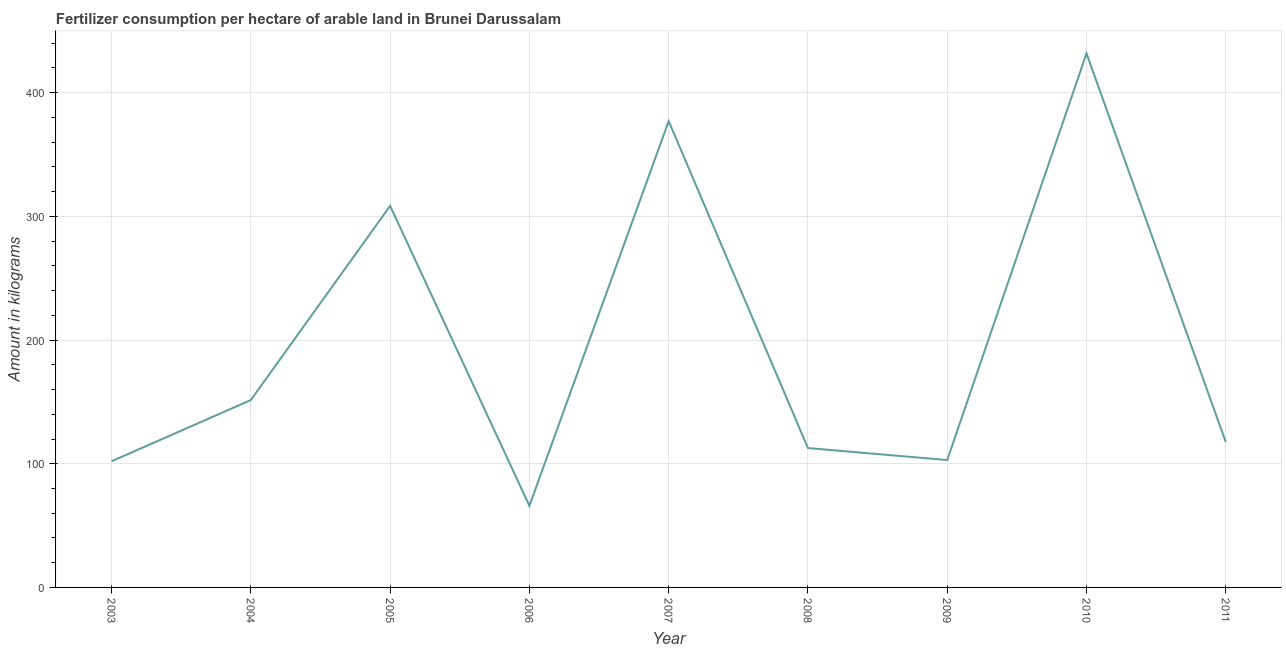What is the amount of fertilizer consumption in 2003?
Your answer should be very brief. 102. Across all years, what is the maximum amount of fertilizer consumption?
Ensure brevity in your answer.  431.75. In which year was the amount of fertilizer consumption maximum?
Keep it short and to the point. 2010. What is the sum of the amount of fertilizer consumption?
Give a very brief answer. 1769.92. What is the difference between the amount of fertilizer consumption in 2005 and 2010?
Offer a terse response. -123.25. What is the average amount of fertilizer consumption per year?
Make the answer very short. 196.66. What is the median amount of fertilizer consumption?
Provide a succinct answer. 117.5. In how many years, is the amount of fertilizer consumption greater than 60 kg?
Your answer should be very brief. 9. Do a majority of the years between 2004 and 2008 (inclusive) have amount of fertilizer consumption greater than 160 kg?
Keep it short and to the point. No. What is the ratio of the amount of fertilizer consumption in 2003 to that in 2011?
Your response must be concise. 0.87. Is the amount of fertilizer consumption in 2005 less than that in 2009?
Give a very brief answer. No. What is the difference between the highest and the second highest amount of fertilizer consumption?
Give a very brief answer. 54.75. What is the difference between the highest and the lowest amount of fertilizer consumption?
Your answer should be compact. 365.75. In how many years, is the amount of fertilizer consumption greater than the average amount of fertilizer consumption taken over all years?
Offer a terse response. 3. Does the graph contain grids?
Give a very brief answer. Yes. What is the title of the graph?
Offer a terse response. Fertilizer consumption per hectare of arable land in Brunei Darussalam . What is the label or title of the X-axis?
Give a very brief answer. Year. What is the label or title of the Y-axis?
Your response must be concise. Amount in kilograms. What is the Amount in kilograms in 2003?
Give a very brief answer. 102. What is the Amount in kilograms of 2004?
Provide a succinct answer. 151.5. What is the Amount in kilograms in 2005?
Ensure brevity in your answer.  308.5. What is the Amount in kilograms in 2006?
Give a very brief answer. 66. What is the Amount in kilograms in 2007?
Ensure brevity in your answer.  377. What is the Amount in kilograms of 2008?
Provide a succinct answer. 112.67. What is the Amount in kilograms in 2009?
Keep it short and to the point. 103. What is the Amount in kilograms of 2010?
Offer a terse response. 431.75. What is the Amount in kilograms of 2011?
Your response must be concise. 117.5. What is the difference between the Amount in kilograms in 2003 and 2004?
Offer a very short reply. -49.5. What is the difference between the Amount in kilograms in 2003 and 2005?
Ensure brevity in your answer.  -206.5. What is the difference between the Amount in kilograms in 2003 and 2006?
Ensure brevity in your answer.  36. What is the difference between the Amount in kilograms in 2003 and 2007?
Ensure brevity in your answer.  -275. What is the difference between the Amount in kilograms in 2003 and 2008?
Offer a very short reply. -10.67. What is the difference between the Amount in kilograms in 2003 and 2009?
Keep it short and to the point. -1. What is the difference between the Amount in kilograms in 2003 and 2010?
Give a very brief answer. -329.75. What is the difference between the Amount in kilograms in 2003 and 2011?
Offer a terse response. -15.5. What is the difference between the Amount in kilograms in 2004 and 2005?
Ensure brevity in your answer.  -157. What is the difference between the Amount in kilograms in 2004 and 2006?
Your answer should be very brief. 85.5. What is the difference between the Amount in kilograms in 2004 and 2007?
Give a very brief answer. -225.5. What is the difference between the Amount in kilograms in 2004 and 2008?
Make the answer very short. 38.83. What is the difference between the Amount in kilograms in 2004 and 2009?
Ensure brevity in your answer.  48.5. What is the difference between the Amount in kilograms in 2004 and 2010?
Provide a succinct answer. -280.25. What is the difference between the Amount in kilograms in 2004 and 2011?
Offer a very short reply. 34. What is the difference between the Amount in kilograms in 2005 and 2006?
Offer a terse response. 242.5. What is the difference between the Amount in kilograms in 2005 and 2007?
Your response must be concise. -68.5. What is the difference between the Amount in kilograms in 2005 and 2008?
Give a very brief answer. 195.83. What is the difference between the Amount in kilograms in 2005 and 2009?
Provide a short and direct response. 205.5. What is the difference between the Amount in kilograms in 2005 and 2010?
Offer a terse response. -123.25. What is the difference between the Amount in kilograms in 2005 and 2011?
Make the answer very short. 191. What is the difference between the Amount in kilograms in 2006 and 2007?
Keep it short and to the point. -311. What is the difference between the Amount in kilograms in 2006 and 2008?
Keep it short and to the point. -46.67. What is the difference between the Amount in kilograms in 2006 and 2009?
Give a very brief answer. -37. What is the difference between the Amount in kilograms in 2006 and 2010?
Offer a terse response. -365.75. What is the difference between the Amount in kilograms in 2006 and 2011?
Your answer should be very brief. -51.5. What is the difference between the Amount in kilograms in 2007 and 2008?
Provide a short and direct response. 264.33. What is the difference between the Amount in kilograms in 2007 and 2009?
Ensure brevity in your answer.  274. What is the difference between the Amount in kilograms in 2007 and 2010?
Keep it short and to the point. -54.75. What is the difference between the Amount in kilograms in 2007 and 2011?
Offer a very short reply. 259.5. What is the difference between the Amount in kilograms in 2008 and 2009?
Provide a succinct answer. 9.67. What is the difference between the Amount in kilograms in 2008 and 2010?
Your answer should be compact. -319.08. What is the difference between the Amount in kilograms in 2008 and 2011?
Your answer should be very brief. -4.83. What is the difference between the Amount in kilograms in 2009 and 2010?
Keep it short and to the point. -328.75. What is the difference between the Amount in kilograms in 2009 and 2011?
Keep it short and to the point. -14.5. What is the difference between the Amount in kilograms in 2010 and 2011?
Keep it short and to the point. 314.25. What is the ratio of the Amount in kilograms in 2003 to that in 2004?
Your answer should be very brief. 0.67. What is the ratio of the Amount in kilograms in 2003 to that in 2005?
Ensure brevity in your answer.  0.33. What is the ratio of the Amount in kilograms in 2003 to that in 2006?
Give a very brief answer. 1.54. What is the ratio of the Amount in kilograms in 2003 to that in 2007?
Your answer should be compact. 0.27. What is the ratio of the Amount in kilograms in 2003 to that in 2008?
Offer a very short reply. 0.91. What is the ratio of the Amount in kilograms in 2003 to that in 2010?
Offer a terse response. 0.24. What is the ratio of the Amount in kilograms in 2003 to that in 2011?
Give a very brief answer. 0.87. What is the ratio of the Amount in kilograms in 2004 to that in 2005?
Provide a succinct answer. 0.49. What is the ratio of the Amount in kilograms in 2004 to that in 2006?
Offer a very short reply. 2.29. What is the ratio of the Amount in kilograms in 2004 to that in 2007?
Offer a terse response. 0.4. What is the ratio of the Amount in kilograms in 2004 to that in 2008?
Make the answer very short. 1.34. What is the ratio of the Amount in kilograms in 2004 to that in 2009?
Offer a very short reply. 1.47. What is the ratio of the Amount in kilograms in 2004 to that in 2010?
Provide a succinct answer. 0.35. What is the ratio of the Amount in kilograms in 2004 to that in 2011?
Your response must be concise. 1.29. What is the ratio of the Amount in kilograms in 2005 to that in 2006?
Provide a short and direct response. 4.67. What is the ratio of the Amount in kilograms in 2005 to that in 2007?
Offer a very short reply. 0.82. What is the ratio of the Amount in kilograms in 2005 to that in 2008?
Offer a terse response. 2.74. What is the ratio of the Amount in kilograms in 2005 to that in 2009?
Make the answer very short. 3. What is the ratio of the Amount in kilograms in 2005 to that in 2010?
Give a very brief answer. 0.71. What is the ratio of the Amount in kilograms in 2005 to that in 2011?
Your answer should be compact. 2.63. What is the ratio of the Amount in kilograms in 2006 to that in 2007?
Offer a very short reply. 0.17. What is the ratio of the Amount in kilograms in 2006 to that in 2008?
Give a very brief answer. 0.59. What is the ratio of the Amount in kilograms in 2006 to that in 2009?
Offer a very short reply. 0.64. What is the ratio of the Amount in kilograms in 2006 to that in 2010?
Provide a short and direct response. 0.15. What is the ratio of the Amount in kilograms in 2006 to that in 2011?
Offer a terse response. 0.56. What is the ratio of the Amount in kilograms in 2007 to that in 2008?
Your answer should be compact. 3.35. What is the ratio of the Amount in kilograms in 2007 to that in 2009?
Offer a terse response. 3.66. What is the ratio of the Amount in kilograms in 2007 to that in 2010?
Make the answer very short. 0.87. What is the ratio of the Amount in kilograms in 2007 to that in 2011?
Your answer should be very brief. 3.21. What is the ratio of the Amount in kilograms in 2008 to that in 2009?
Ensure brevity in your answer.  1.09. What is the ratio of the Amount in kilograms in 2008 to that in 2010?
Keep it short and to the point. 0.26. What is the ratio of the Amount in kilograms in 2009 to that in 2010?
Offer a terse response. 0.24. What is the ratio of the Amount in kilograms in 2009 to that in 2011?
Provide a succinct answer. 0.88. What is the ratio of the Amount in kilograms in 2010 to that in 2011?
Provide a short and direct response. 3.67. 